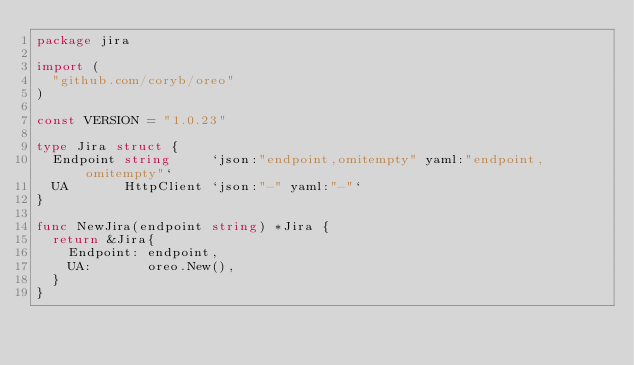<code> <loc_0><loc_0><loc_500><loc_500><_Go_>package jira

import (
	"github.com/coryb/oreo"
)

const VERSION = "1.0.23"

type Jira struct {
	Endpoint string     `json:"endpoint,omitempty" yaml:"endpoint,omitempty"`
	UA       HttpClient `json:"-" yaml:"-"`
}

func NewJira(endpoint string) *Jira {
	return &Jira{
		Endpoint: endpoint,
		UA:       oreo.New(),
	}
}
</code> 